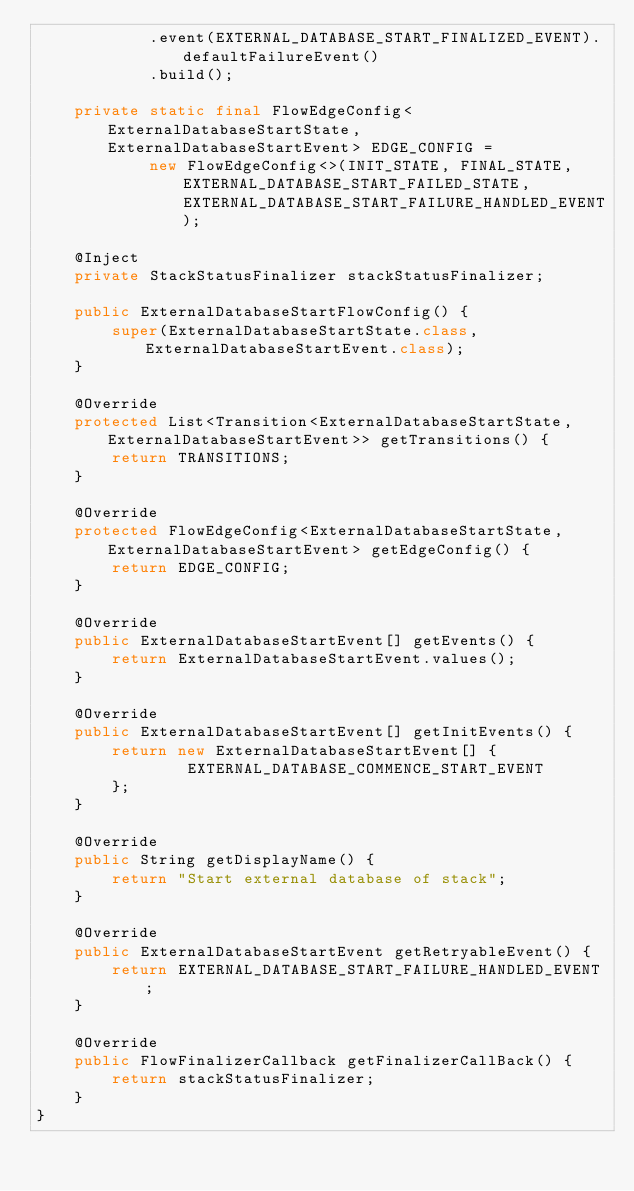<code> <loc_0><loc_0><loc_500><loc_500><_Java_>            .event(EXTERNAL_DATABASE_START_FINALIZED_EVENT).defaultFailureEvent()
            .build();

    private static final FlowEdgeConfig<ExternalDatabaseStartState, ExternalDatabaseStartEvent> EDGE_CONFIG =
            new FlowEdgeConfig<>(INIT_STATE, FINAL_STATE, EXTERNAL_DATABASE_START_FAILED_STATE, EXTERNAL_DATABASE_START_FAILURE_HANDLED_EVENT);

    @Inject
    private StackStatusFinalizer stackStatusFinalizer;

    public ExternalDatabaseStartFlowConfig() {
        super(ExternalDatabaseStartState.class, ExternalDatabaseStartEvent.class);
    }

    @Override
    protected List<Transition<ExternalDatabaseStartState, ExternalDatabaseStartEvent>> getTransitions() {
        return TRANSITIONS;
    }

    @Override
    protected FlowEdgeConfig<ExternalDatabaseStartState, ExternalDatabaseStartEvent> getEdgeConfig() {
        return EDGE_CONFIG;
    }

    @Override
    public ExternalDatabaseStartEvent[] getEvents() {
        return ExternalDatabaseStartEvent.values();
    }

    @Override
    public ExternalDatabaseStartEvent[] getInitEvents() {
        return new ExternalDatabaseStartEvent[] {
                EXTERNAL_DATABASE_COMMENCE_START_EVENT
        };
    }

    @Override
    public String getDisplayName() {
        return "Start external database of stack";
    }

    @Override
    public ExternalDatabaseStartEvent getRetryableEvent() {
        return EXTERNAL_DATABASE_START_FAILURE_HANDLED_EVENT;
    }

    @Override
    public FlowFinalizerCallback getFinalizerCallBack() {
        return stackStatusFinalizer;
    }
}
</code> 